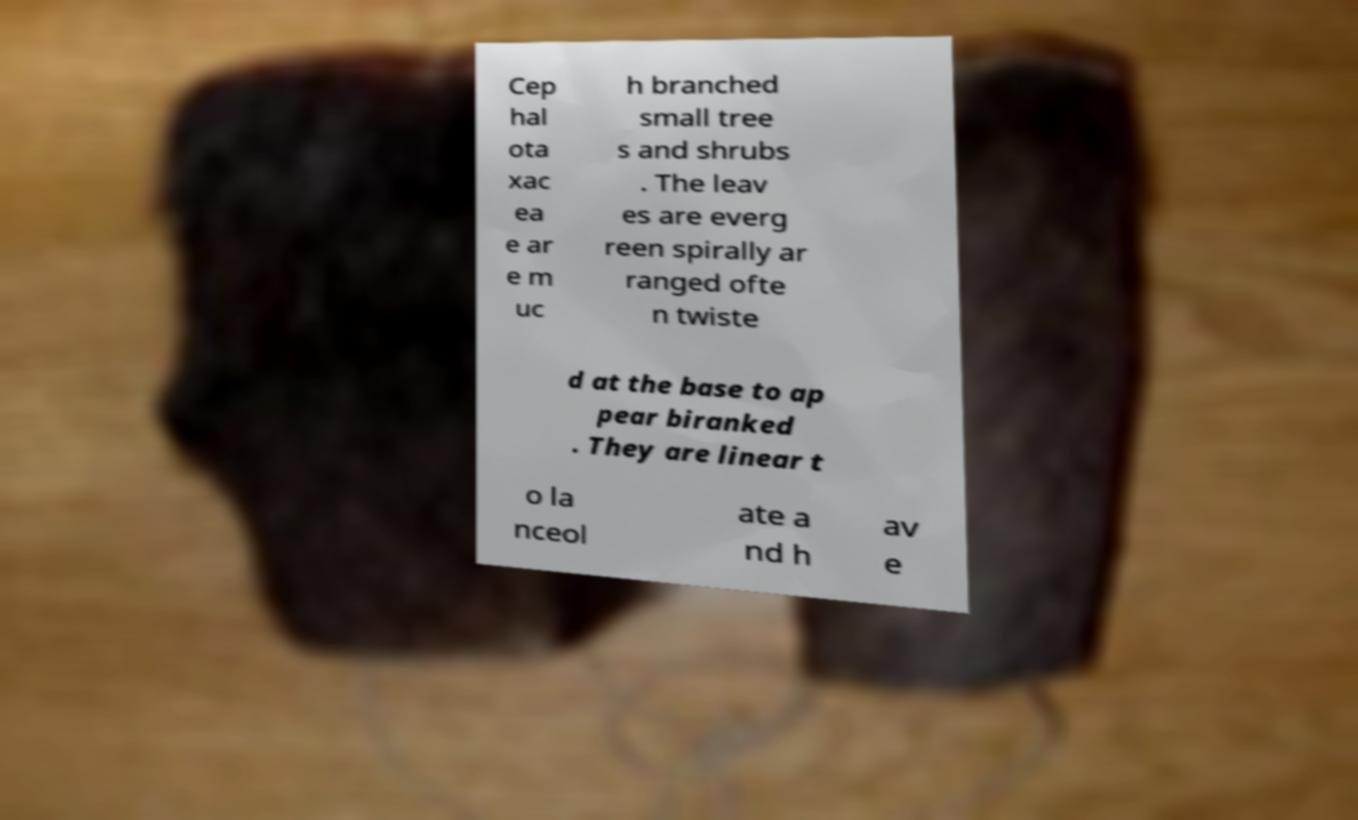Can you accurately transcribe the text from the provided image for me? Cep hal ota xac ea e ar e m uc h branched small tree s and shrubs . The leav es are everg reen spirally ar ranged ofte n twiste d at the base to ap pear biranked . They are linear t o la nceol ate a nd h av e 